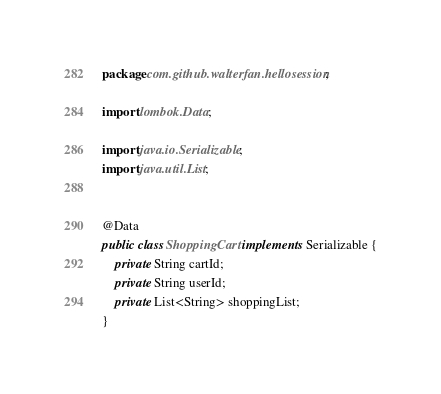Convert code to text. <code><loc_0><loc_0><loc_500><loc_500><_Java_>package com.github.walterfan.hellosession;

import lombok.Data;

import java.io.Serializable;
import java.util.List;


@Data
public class ShoppingCart implements Serializable {
    private String cartId;
    private String userId;
    private List<String> shoppingList;
}
</code> 